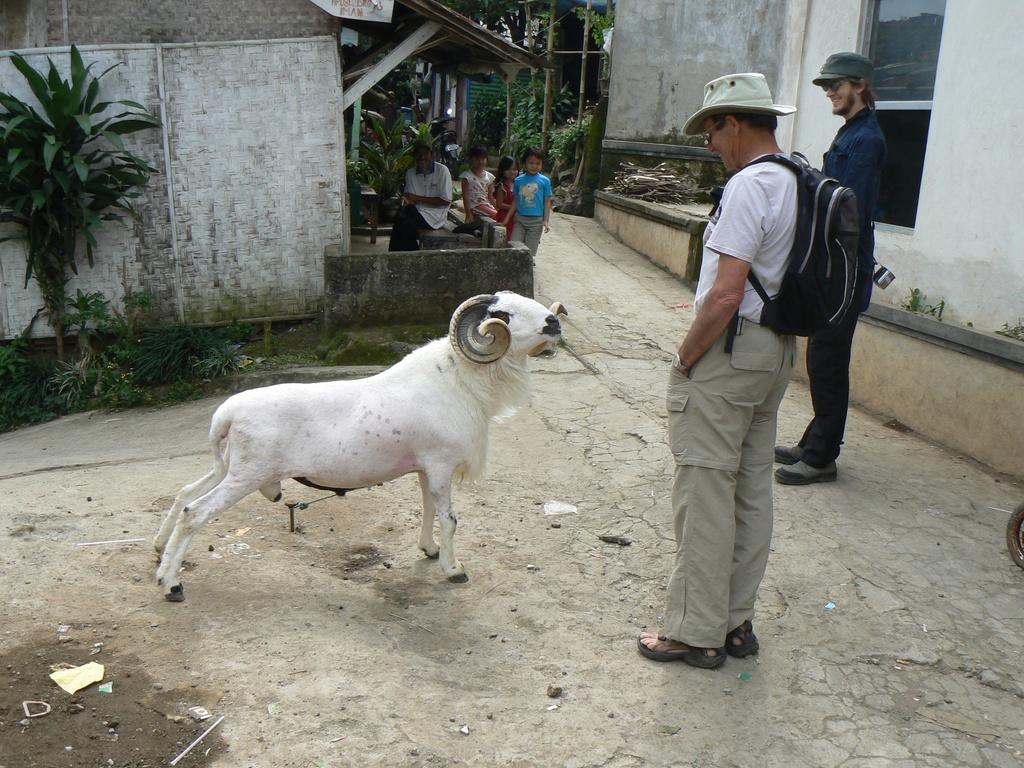What type of structures can be seen in the image? There are houses in the image. What other elements can be found in the image? There are plants, trees, people, and a window in the image. Can you describe the presence of any animals in the image? Yes, there is a white-colored sheep in the image. What type of cart is being pulled by the sheep in the image? There is no cart present in the image, and the sheep is not pulling anything. 